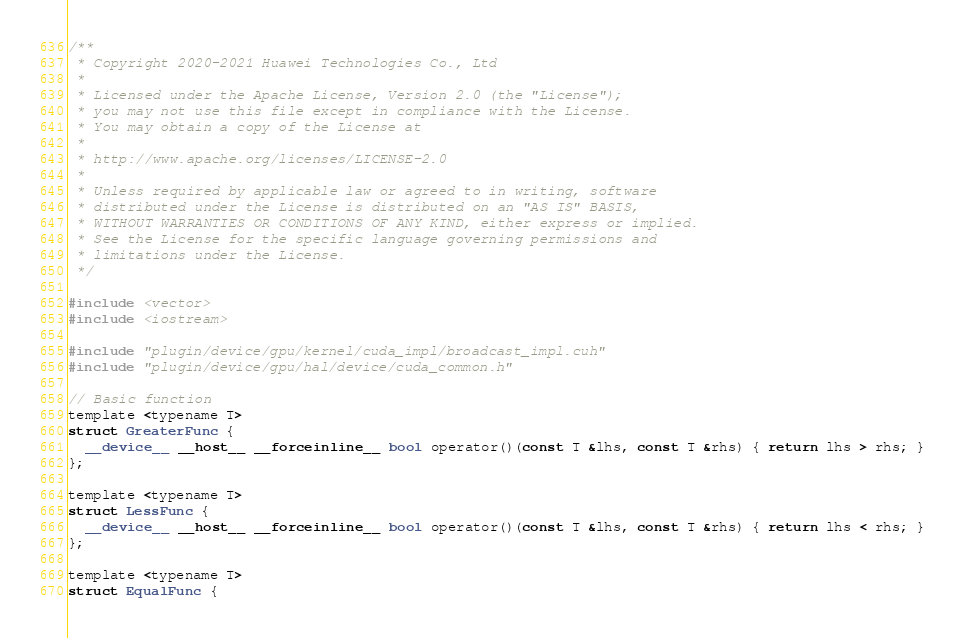<code> <loc_0><loc_0><loc_500><loc_500><_Cuda_>/**
 * Copyright 2020-2021 Huawei Technologies Co., Ltd
 *
 * Licensed under the Apache License, Version 2.0 (the "License");
 * you may not use this file except in compliance with the License.
 * You may obtain a copy of the License at
 *
 * http://www.apache.org/licenses/LICENSE-2.0
 *
 * Unless required by applicable law or agreed to in writing, software
 * distributed under the License is distributed on an "AS IS" BASIS,
 * WITHOUT WARRANTIES OR CONDITIONS OF ANY KIND, either express or implied.
 * See the License for the specific language governing permissions and
 * limitations under the License.
 */

#include <vector>
#include <iostream>

#include "plugin/device/gpu/kernel/cuda_impl/broadcast_impl.cuh"
#include "plugin/device/gpu/hal/device/cuda_common.h"

// Basic function
template <typename T>
struct GreaterFunc {
  __device__ __host__ __forceinline__ bool operator()(const T &lhs, const T &rhs) { return lhs > rhs; }
};

template <typename T>
struct LessFunc {
  __device__ __host__ __forceinline__ bool operator()(const T &lhs, const T &rhs) { return lhs < rhs; }
};

template <typename T>
struct EqualFunc {</code> 